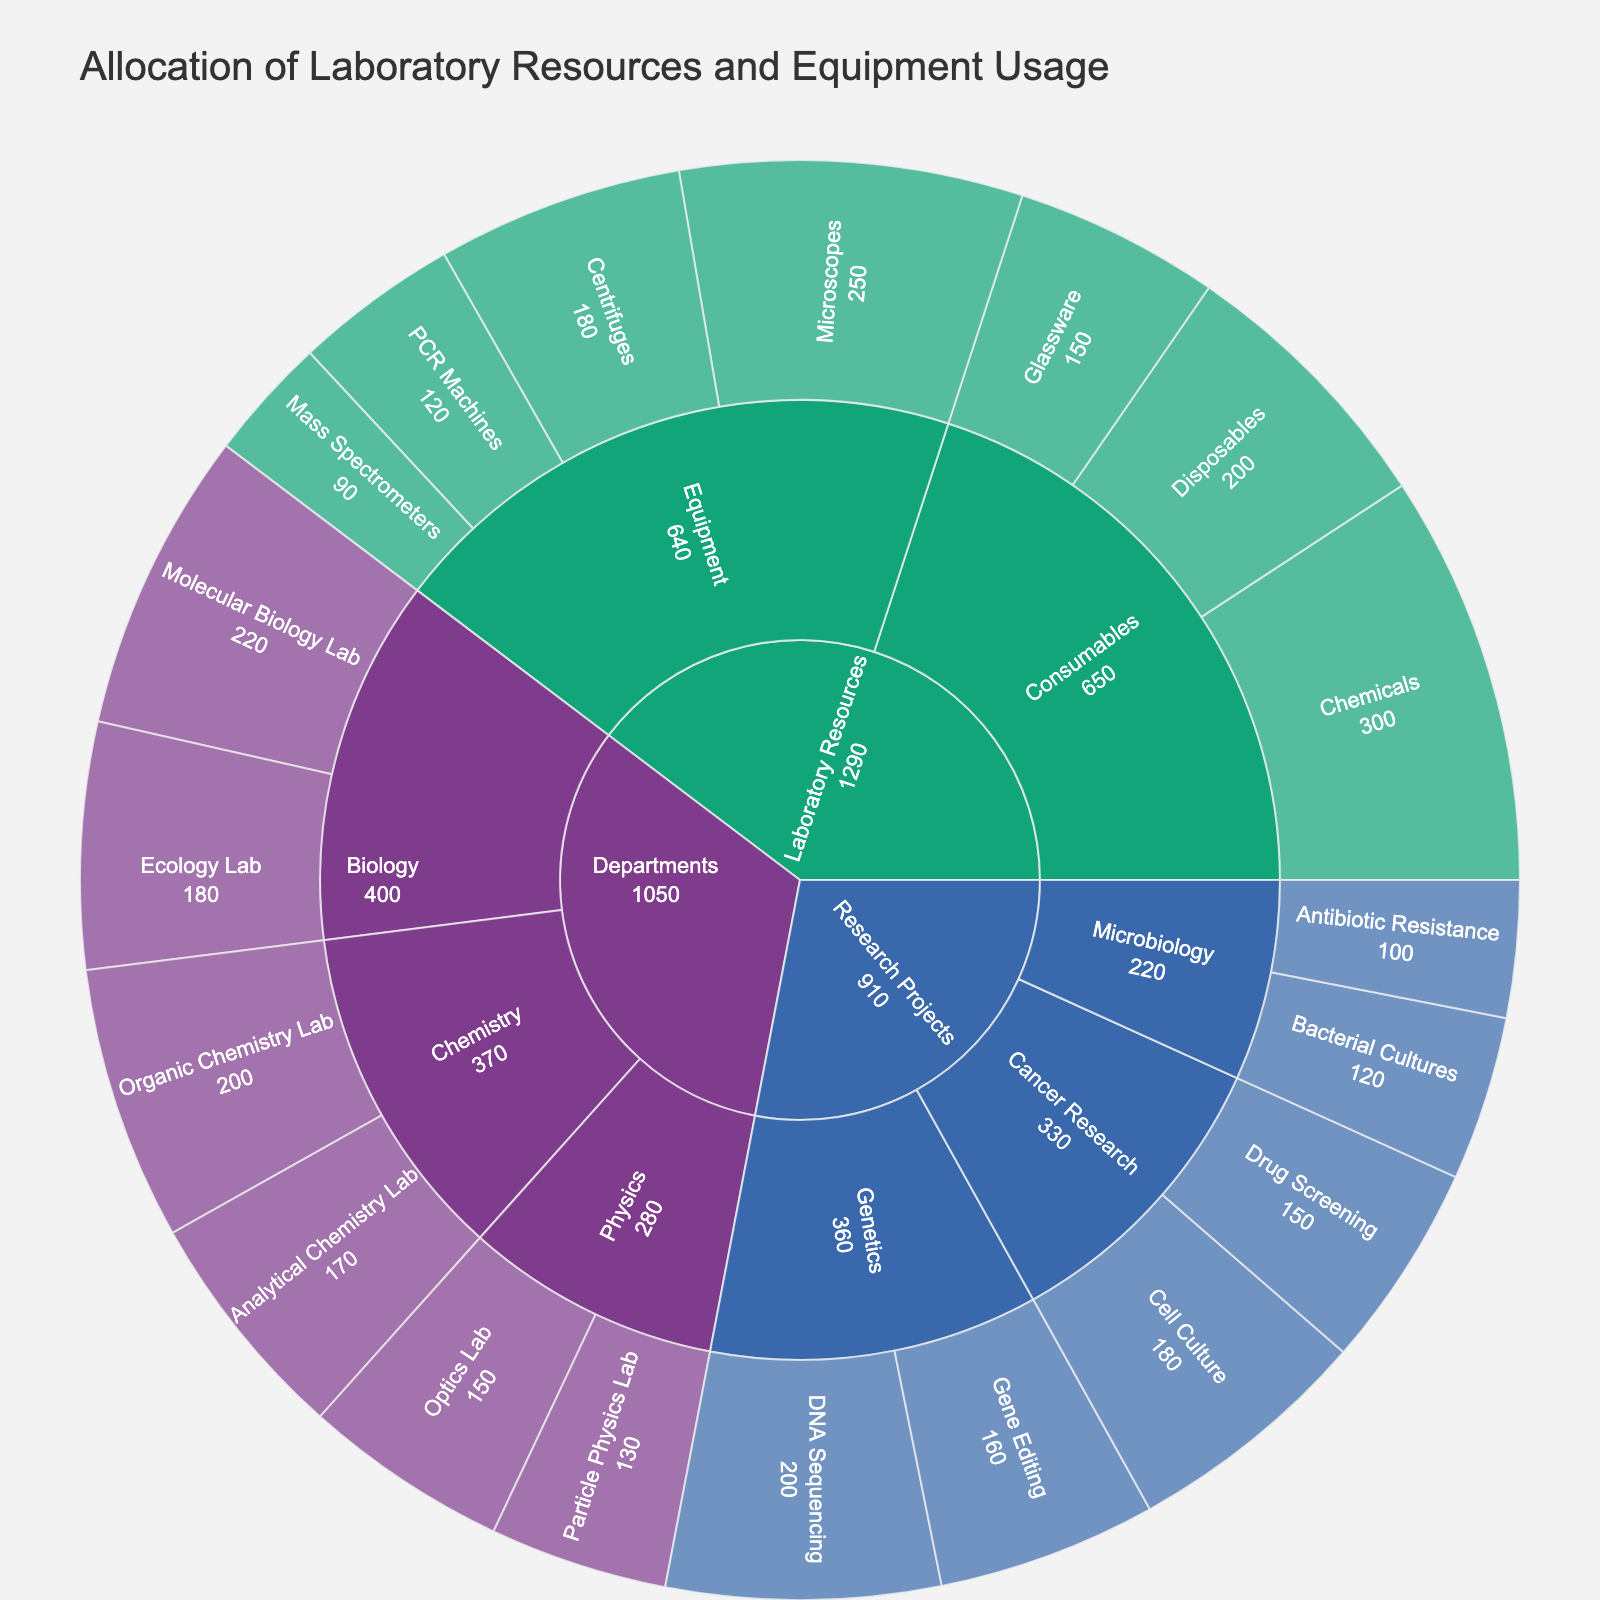What's the title of the sunburst plot? The title is usually displayed at the top of the plot. By looking at this part of the visual, you can see the text explaining what the figure is about.
Answer: Allocation of Laboratory Resources and Equipment Usage What category has the highest total value? To find this, you add up the values of all subcategories within each main category. The category with the highest sum is the one with the highest total value. Laboratory Resources: 1090, Research Projects: 910, Departments: 1050.
Answer: Laboratory Resources How many values are associated with the Biology department? Look for the "Biology" subcategory under the "Departments" category and count the number of subcategories.
Answer: 2 What is the total value for the Chemistry department? To find this, sum up the values associated with the "Organic Chemistry Lab" and "Analytical Chemistry Lab" subsubcategories under the Chemistry department. 200 (Organic Chemistry Lab) + 170 (Analytical Chemistry Lab) = 370
Answer: 370 Which equipment type has the least value assigned? Examine the values under the "Equipment" subcategory within "Laboratory Resources." Identifying the smallest number can help you answer this. 250 (Microscopes), 180 (Centrifuges), 120 (PCR Machines), 90 (Mass Spectrometers)
Answer: Mass Spectrometers What is the combined value of all equipment types? Sum up the values of all types within the "Equipment" subcategory under "Laboratory Resources." 250 + 180 + 120 + 90 = 640
Answer: 640 Compare the total value of consumables and equipment in Laboratory Resources. Which is higher? First, total the values in the "Consumables" subcategory: 300 (Chemicals) + 150 (Glassware) + 200 (Disposables) = 650. Then, total the "Equipment" values: 250 (Microscopes) + 180 (Centrifuges) + 120 (PCR Machines) + 90 (Mass Spectrometers) = 640. Then compare these totals.
Answer: Consumables Which research project has the highest value, and what is it? Look into the "Research Projects" category and compare the values for the various sub-subcategories within each subcategory (e.g., Cancer Research, Microbiology, Genetics). Identify the highest value and its associated project. DNA Sequencing (200)
Answer: DNA Sequencing What's the proportion of the value allocated to the Genetics research projects compared to the total value of all research projects? Find the sum of values for the Genetics projects: 200 (DNA Sequencing) + 160 (Gene Editing) = 360. Then, find the total value for all research projects: 180 (Cell Culture) + 150 (Drug Screening) + 120 (Bacterial Cultures) + 100 (Antibiotic Resistance) + 200 (DNA Sequencing) + 160 (Gene Editing) = 910. Calculate the proportion by dividing the Genetics value by the total and multiply by 100 to get the percentage. (360 / 910) * 100 ≈ 39.56
Answer: 39.56% 